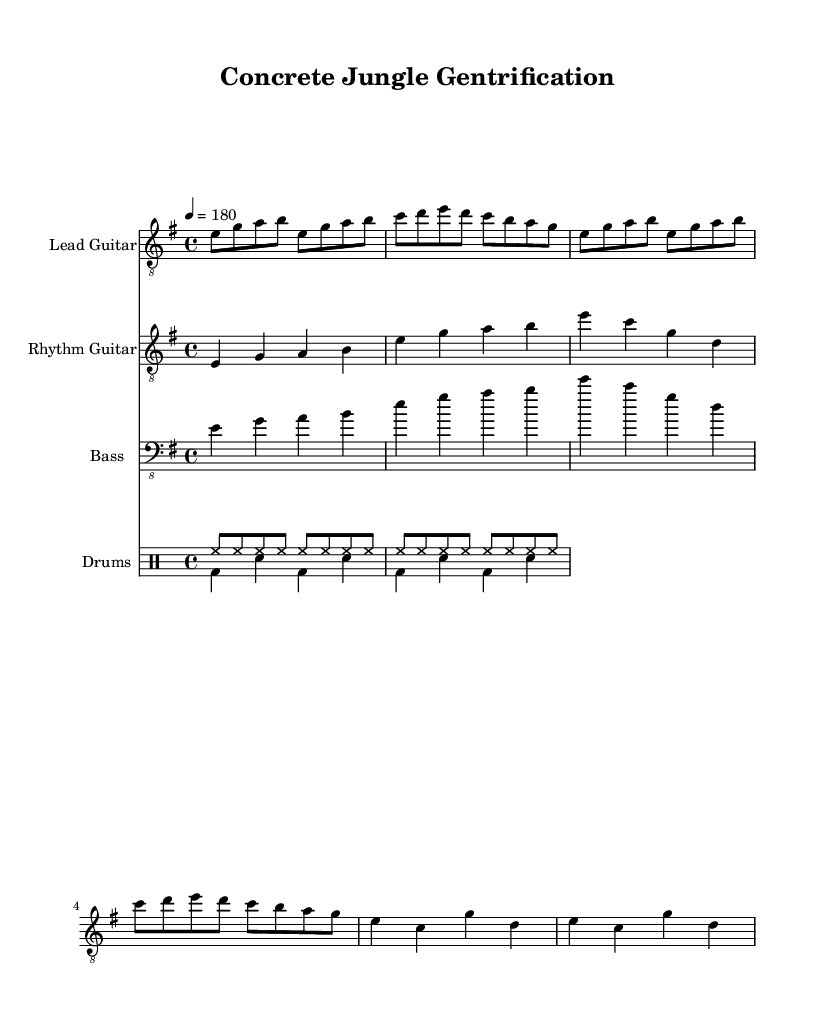What is the key signature of this music? The key signature is E minor, which has one sharp (F#). This can be determined by looking at the key signature section of the music, where E minor is indicated.
Answer: E minor What is the time signature of this music? The time signature is 4/4 as indicated in the beginning of the sheet music. This means there are four beats in each measure and the quarter note gets one beat.
Answer: 4/4 What is the tempo of the piece? The tempo is specified as a quarter note equals 180 beats per minute. This is indicated by the tempo marking at the beginning of the score.
Answer: 180 How many measures are in the main riff? The main riff consists of 4 measures. By counting the measures in the lead guitar part, we can see that it runs for 4 complete measures before moving to the next section.
Answer: 4 What is the rhythmic pattern for the drums in the main riff? The rhythmic pattern consists of eight eighth notes in succession. This is seen in the drum notation under 'drumsUp,' where eight hihat notes are played in a row.
Answer: Eight eighth notes What is the main theme addressed in the lyrics? The theme addressed revolves around gentrification and displacement. While not explicitly detailed in the musical notation, it reflects political themes typical of thrash metal lyrics.
Answer: Gentrification and displacement What instrument plays the lead melody? The lead guitar plays the lead melody, as indicated by its part labeled 'Lead Guitar' in the score. The notation for the lead guitar features higher pitch and more melodic content compared to others.
Answer: Lead guitar 